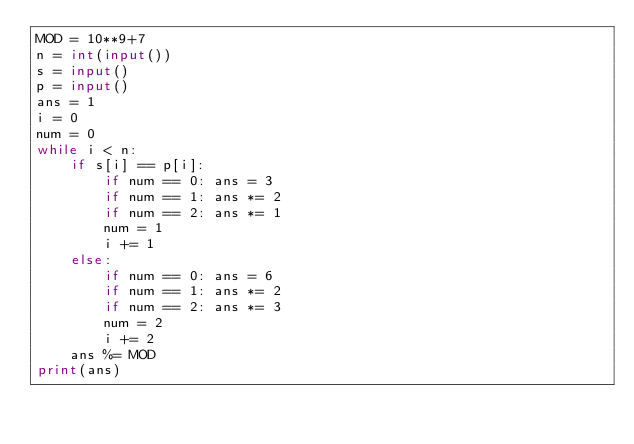<code> <loc_0><loc_0><loc_500><loc_500><_Python_>MOD = 10**9+7
n = int(input())
s = input()
p = input()
ans = 1
i = 0
num = 0
while i < n:
    if s[i] == p[i]:
        if num == 0: ans = 3
        if num == 1: ans *= 2
        if num == 2: ans *= 1
        num = 1
        i += 1
    else:
        if num == 0: ans = 6
        if num == 1: ans *= 2
        if num == 2: ans *= 3
        num = 2
        i += 2
    ans %= MOD
print(ans)
</code> 